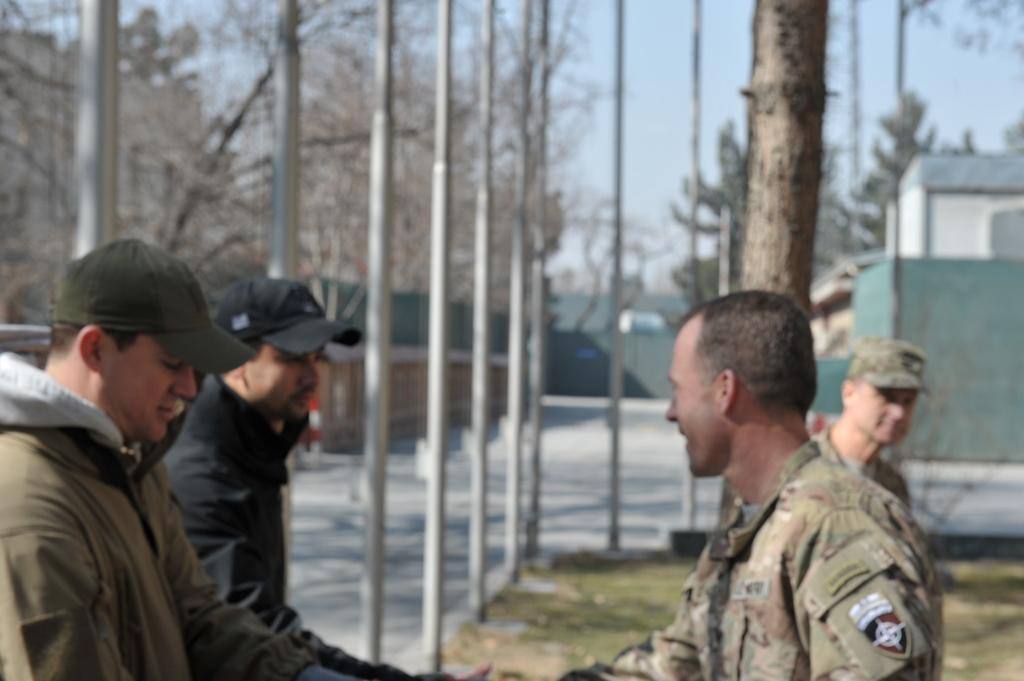How many people are in the image? There are people in the image, but the exact number is not specified. What are some people wearing in the image? Some people are wearing caps in the image. What can be seen in the background of the image? In the background of the image, there are houses, trees, poles, roads, and the sky. Can you describe the environment in the image? The image shows people in a setting with houses, trees, poles, roads, and the sky visible in the background. How many lizards can be seen crawling on the library in the image? There is no library or lizards present in the image. Is there a rabbit hiding behind the trees in the image? There is no rabbit visible in the image; only trees, houses, poles, roads, and the sky are present in the background. 